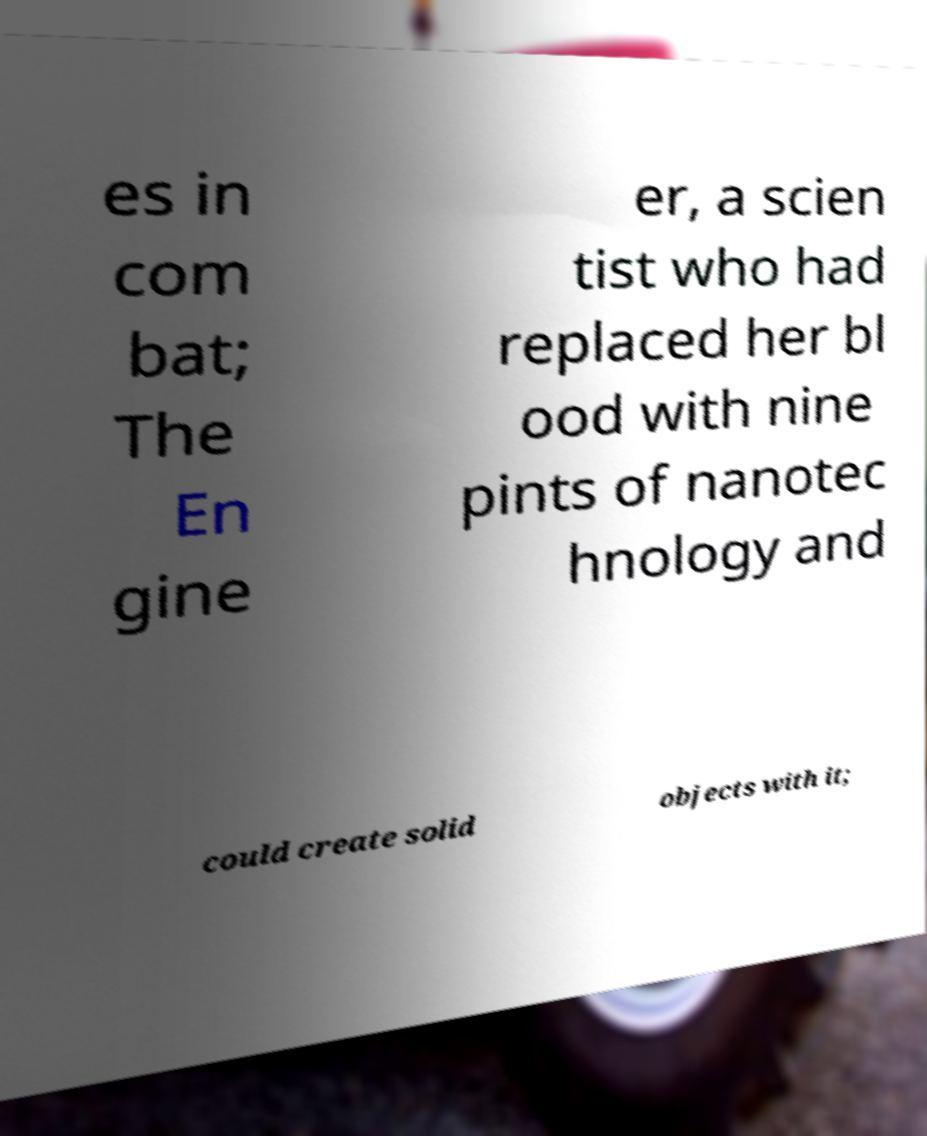Please identify and transcribe the text found in this image. es in com bat; The En gine er, a scien tist who had replaced her bl ood with nine pints of nanotec hnology and could create solid objects with it; 